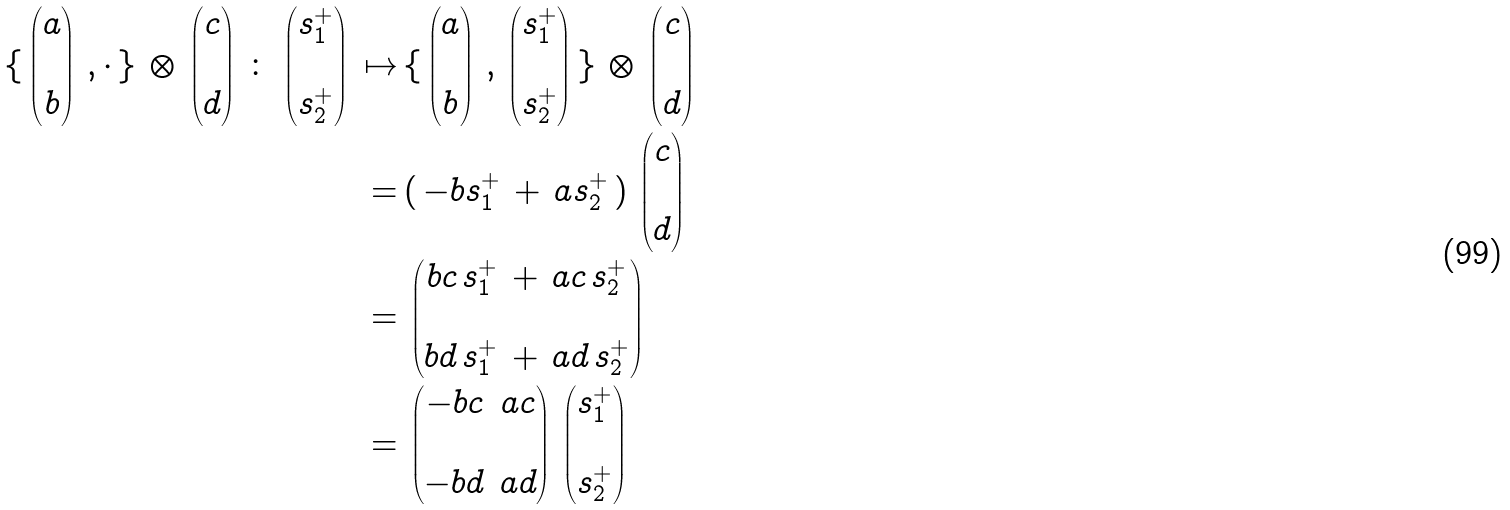<formula> <loc_0><loc_0><loc_500><loc_500>\{ \, \begin{pmatrix} a \\ \\ b \end{pmatrix} \, , \cdot \, \} \, \otimes \, \begin{pmatrix} c \\ \\ d \end{pmatrix} \, \colon \, \begin{pmatrix} s _ { 1 } ^ { + } \\ \\ s _ { 2 } ^ { + } \end{pmatrix} \, \mapsto \, & \{ \, \begin{pmatrix} a \\ \\ b \end{pmatrix} \, , \, \begin{pmatrix} s _ { 1 } ^ { + } \\ \\ s _ { 2 } ^ { + } \end{pmatrix} \, \} \, \otimes \, \begin{pmatrix} c \\ \\ d \end{pmatrix} \\ = \, & ( \, - b s _ { 1 } ^ { + } \, + \, a s _ { 2 } ^ { + } \, ) \, \begin{pmatrix} c \\ \\ d \end{pmatrix} \\ = \, & \begin{pmatrix} b c \, s _ { 1 } ^ { + } \, + \, a c \, s _ { 2 } ^ { + } \\ \\ b d \, s _ { 1 } ^ { + } \, + \, a d \, s _ { 2 } ^ { + } \end{pmatrix} \\ = \, & \begin{pmatrix} - b c & a c \\ \\ - b d & a d \end{pmatrix} \, \begin{pmatrix} s _ { 1 } ^ { + } \\ \\ s _ { 2 } ^ { + } \end{pmatrix}</formula> 